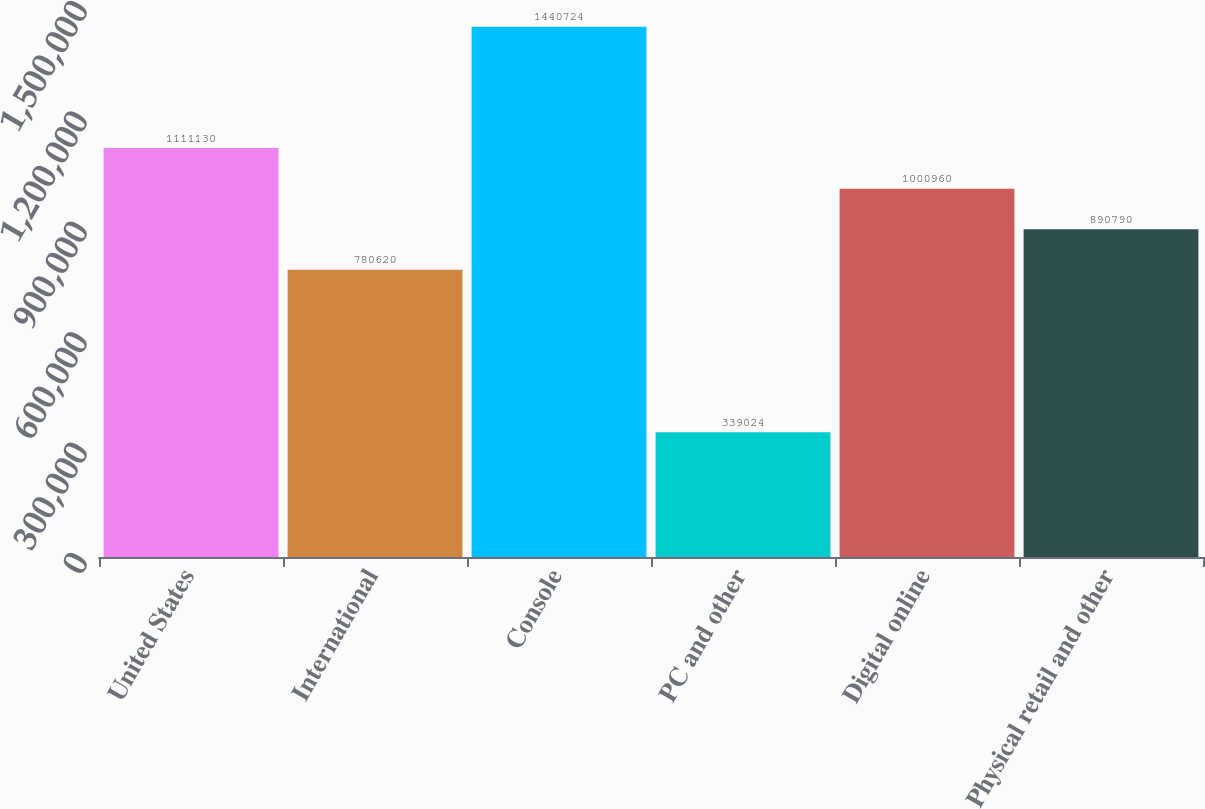Convert chart. <chart><loc_0><loc_0><loc_500><loc_500><bar_chart><fcel>United States<fcel>International<fcel>Console<fcel>PC and other<fcel>Digital online<fcel>Physical retail and other<nl><fcel>1.11113e+06<fcel>780620<fcel>1.44072e+06<fcel>339024<fcel>1.00096e+06<fcel>890790<nl></chart> 